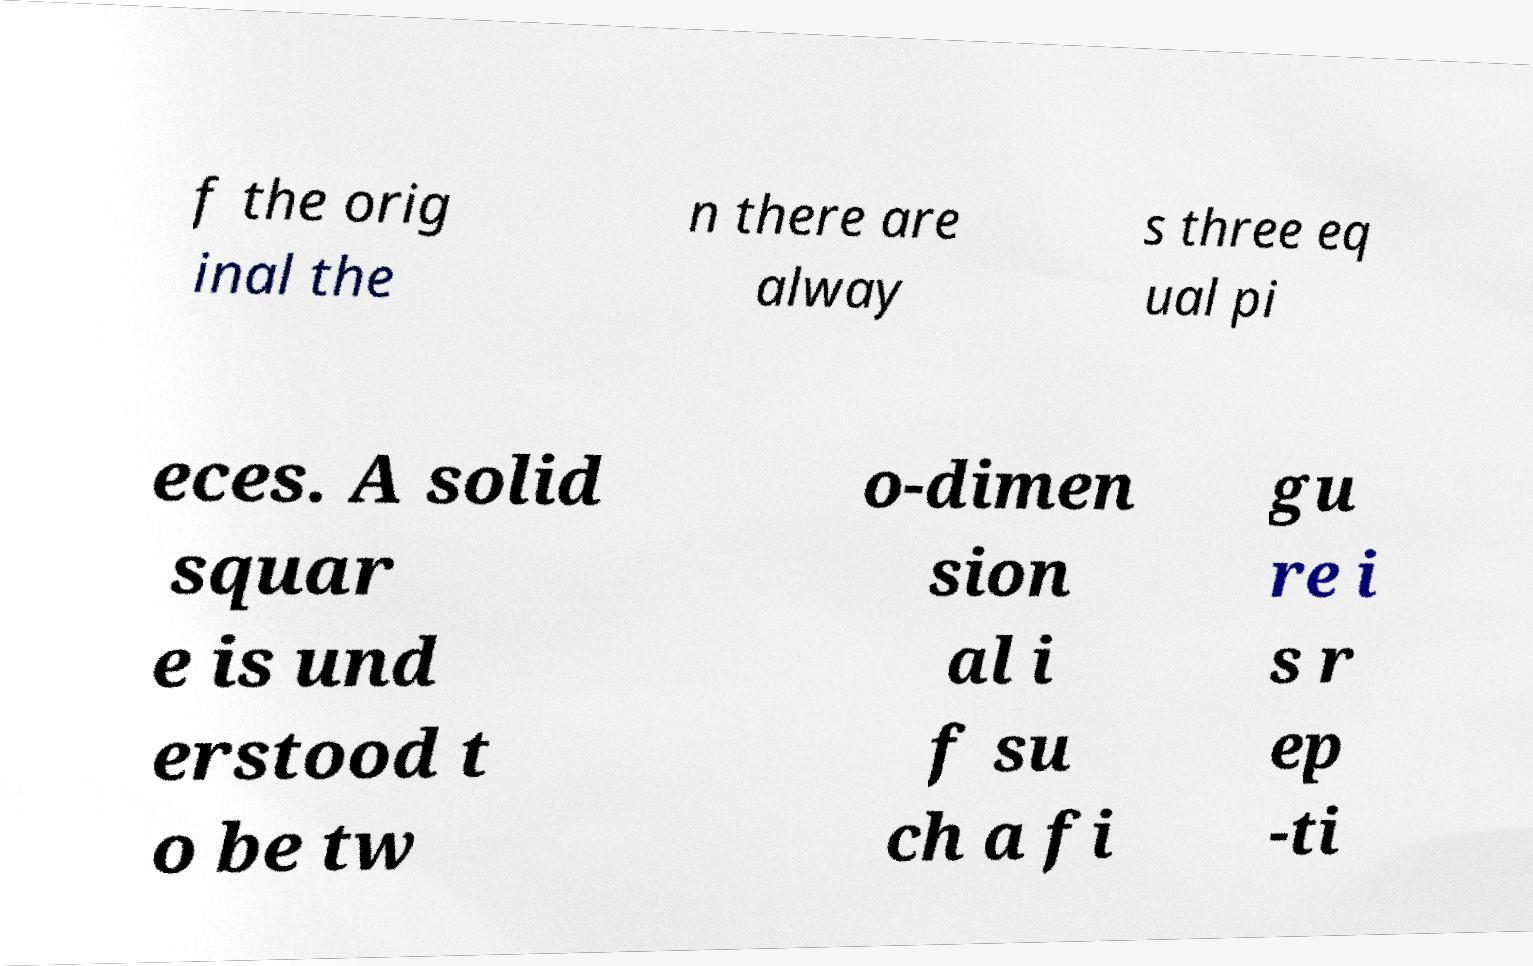Could you extract and type out the text from this image? f the orig inal the n there are alway s three eq ual pi eces. A solid squar e is und erstood t o be tw o-dimen sion al i f su ch a fi gu re i s r ep -ti 